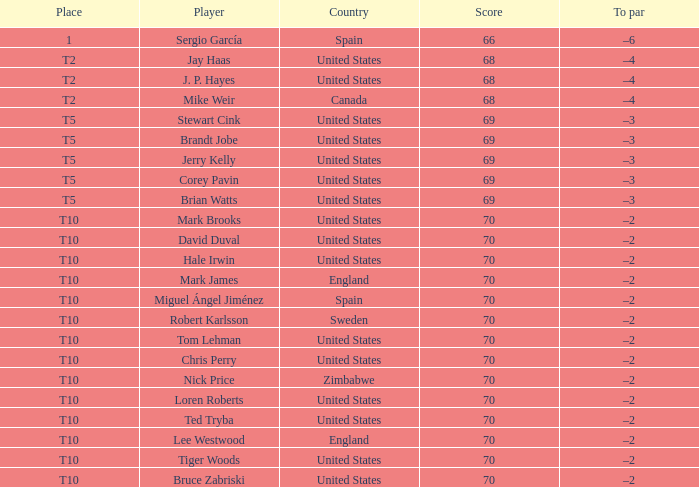Can you identify the player who scored 70 points? Mark Brooks, David Duval, Hale Irwin, Mark James, Miguel Ángel Jiménez, Robert Karlsson, Tom Lehman, Chris Perry, Nick Price, Loren Roberts, Ted Tryba, Lee Westwood, Tiger Woods, Bruce Zabriski. 